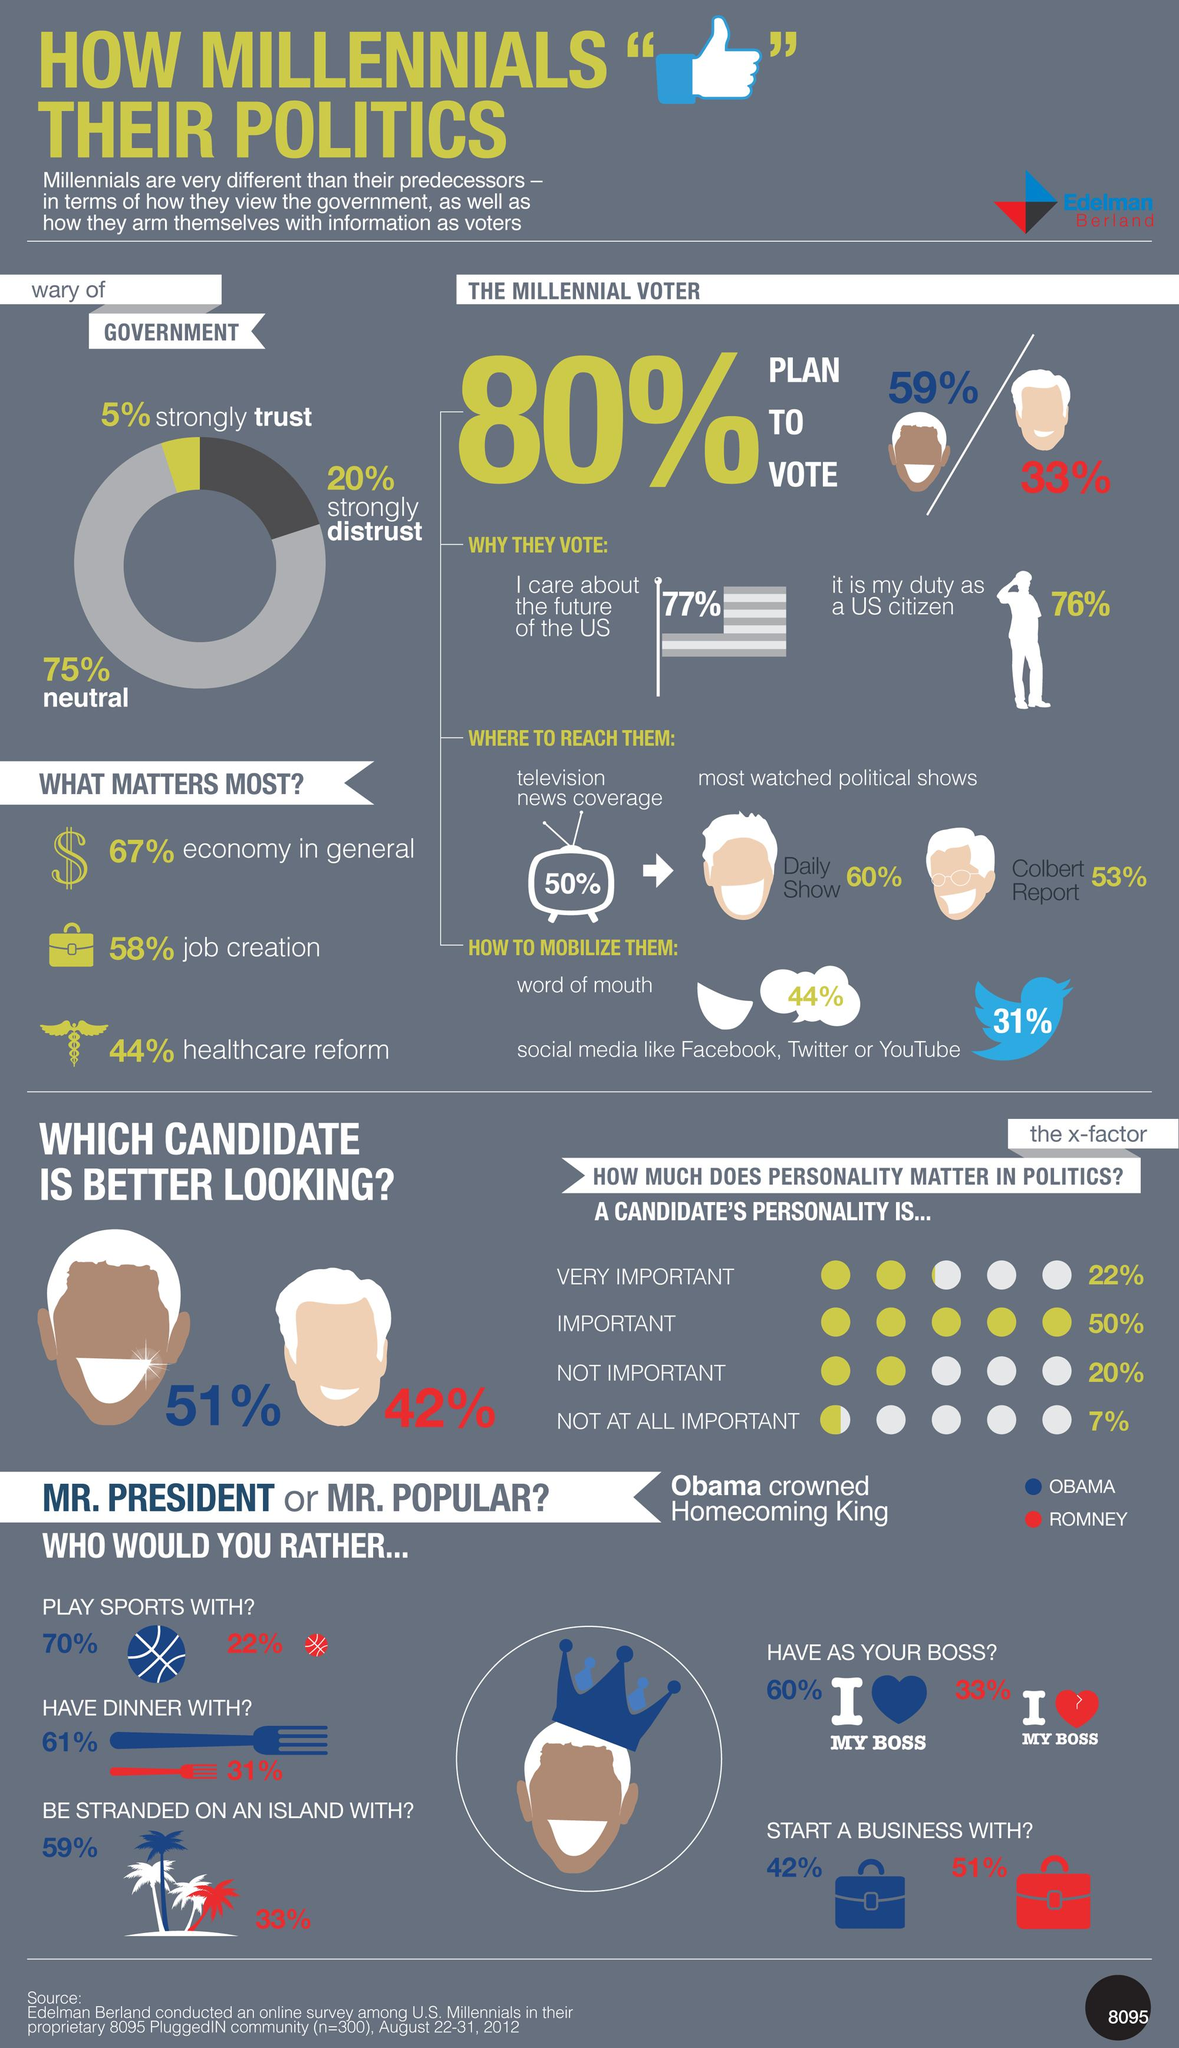Point out several critical features in this image. Approximately 33% of Millennial voters planned to vote for Mitt Romney. The majority preferred to start a business with Mitt Romney. According to a survey, 51% of respondents believed that Obama was more physically attractive. According to a survey, 31% of Millennials expressed a desire to have dinner with Mitt Romney. A recent study has found that 31% of Millennial votes can be mobilized using Twitter. 